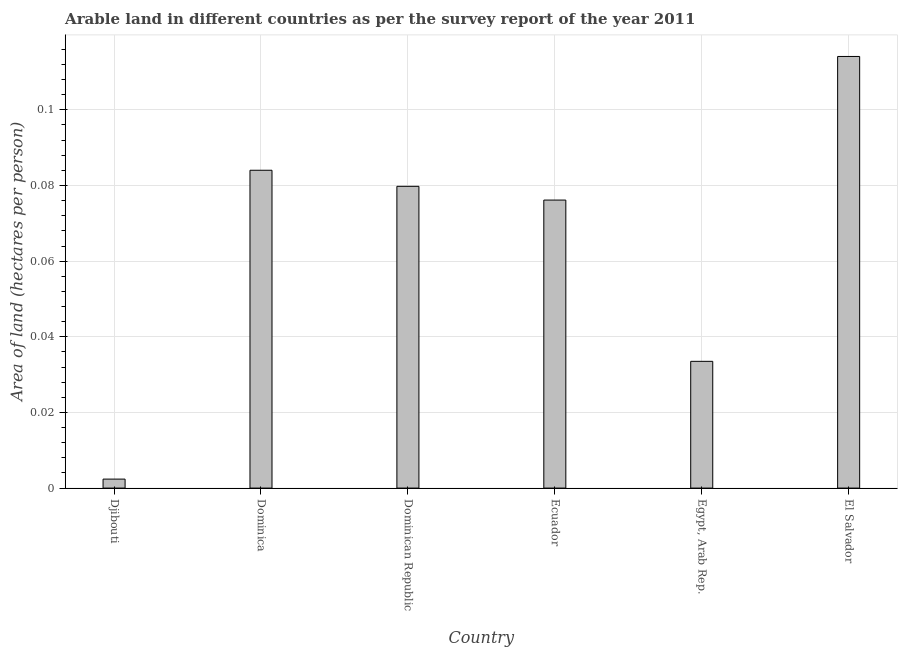Does the graph contain any zero values?
Your answer should be compact. No. Does the graph contain grids?
Your answer should be compact. Yes. What is the title of the graph?
Give a very brief answer. Arable land in different countries as per the survey report of the year 2011. What is the label or title of the X-axis?
Provide a succinct answer. Country. What is the label or title of the Y-axis?
Your answer should be very brief. Area of land (hectares per person). What is the area of arable land in El Salvador?
Provide a succinct answer. 0.11. Across all countries, what is the maximum area of arable land?
Your response must be concise. 0.11. Across all countries, what is the minimum area of arable land?
Provide a short and direct response. 0. In which country was the area of arable land maximum?
Offer a terse response. El Salvador. In which country was the area of arable land minimum?
Your answer should be compact. Djibouti. What is the sum of the area of arable land?
Your answer should be very brief. 0.39. What is the difference between the area of arable land in Dominica and El Salvador?
Provide a short and direct response. -0.03. What is the average area of arable land per country?
Provide a short and direct response. 0.07. What is the median area of arable land?
Your answer should be very brief. 0.08. In how many countries, is the area of arable land greater than 0.068 hectares per person?
Ensure brevity in your answer.  4. What is the ratio of the area of arable land in Dominica to that in Egypt, Arab Rep.?
Offer a very short reply. 2.51. Is the difference between the area of arable land in Dominican Republic and El Salvador greater than the difference between any two countries?
Ensure brevity in your answer.  No. What is the difference between the highest and the lowest area of arable land?
Provide a short and direct response. 0.11. In how many countries, is the area of arable land greater than the average area of arable land taken over all countries?
Provide a short and direct response. 4. How many countries are there in the graph?
Your response must be concise. 6. What is the difference between two consecutive major ticks on the Y-axis?
Provide a succinct answer. 0.02. Are the values on the major ticks of Y-axis written in scientific E-notation?
Your answer should be compact. No. What is the Area of land (hectares per person) in Djibouti?
Provide a short and direct response. 0. What is the Area of land (hectares per person) of Dominica?
Offer a very short reply. 0.08. What is the Area of land (hectares per person) in Dominican Republic?
Provide a short and direct response. 0.08. What is the Area of land (hectares per person) of Ecuador?
Provide a short and direct response. 0.08. What is the Area of land (hectares per person) in Egypt, Arab Rep.?
Keep it short and to the point. 0.03. What is the Area of land (hectares per person) in El Salvador?
Your response must be concise. 0.11. What is the difference between the Area of land (hectares per person) in Djibouti and Dominica?
Offer a very short reply. -0.08. What is the difference between the Area of land (hectares per person) in Djibouti and Dominican Republic?
Give a very brief answer. -0.08. What is the difference between the Area of land (hectares per person) in Djibouti and Ecuador?
Your answer should be compact. -0.07. What is the difference between the Area of land (hectares per person) in Djibouti and Egypt, Arab Rep.?
Make the answer very short. -0.03. What is the difference between the Area of land (hectares per person) in Djibouti and El Salvador?
Your answer should be compact. -0.11. What is the difference between the Area of land (hectares per person) in Dominica and Dominican Republic?
Ensure brevity in your answer.  0. What is the difference between the Area of land (hectares per person) in Dominica and Ecuador?
Your answer should be compact. 0.01. What is the difference between the Area of land (hectares per person) in Dominica and Egypt, Arab Rep.?
Your answer should be very brief. 0.05. What is the difference between the Area of land (hectares per person) in Dominica and El Salvador?
Your answer should be very brief. -0.03. What is the difference between the Area of land (hectares per person) in Dominican Republic and Ecuador?
Your answer should be compact. 0. What is the difference between the Area of land (hectares per person) in Dominican Republic and Egypt, Arab Rep.?
Your answer should be very brief. 0.05. What is the difference between the Area of land (hectares per person) in Dominican Republic and El Salvador?
Your answer should be compact. -0.03. What is the difference between the Area of land (hectares per person) in Ecuador and Egypt, Arab Rep.?
Provide a short and direct response. 0.04. What is the difference between the Area of land (hectares per person) in Ecuador and El Salvador?
Your answer should be very brief. -0.04. What is the difference between the Area of land (hectares per person) in Egypt, Arab Rep. and El Salvador?
Offer a terse response. -0.08. What is the ratio of the Area of land (hectares per person) in Djibouti to that in Dominica?
Make the answer very short. 0.03. What is the ratio of the Area of land (hectares per person) in Djibouti to that in Dominican Republic?
Your response must be concise. 0.03. What is the ratio of the Area of land (hectares per person) in Djibouti to that in Ecuador?
Make the answer very short. 0.03. What is the ratio of the Area of land (hectares per person) in Djibouti to that in Egypt, Arab Rep.?
Provide a succinct answer. 0.07. What is the ratio of the Area of land (hectares per person) in Djibouti to that in El Salvador?
Give a very brief answer. 0.02. What is the ratio of the Area of land (hectares per person) in Dominica to that in Dominican Republic?
Your answer should be very brief. 1.05. What is the ratio of the Area of land (hectares per person) in Dominica to that in Ecuador?
Your response must be concise. 1.1. What is the ratio of the Area of land (hectares per person) in Dominica to that in Egypt, Arab Rep.?
Offer a very short reply. 2.51. What is the ratio of the Area of land (hectares per person) in Dominica to that in El Salvador?
Provide a succinct answer. 0.74. What is the ratio of the Area of land (hectares per person) in Dominican Republic to that in Ecuador?
Keep it short and to the point. 1.05. What is the ratio of the Area of land (hectares per person) in Dominican Republic to that in Egypt, Arab Rep.?
Offer a very short reply. 2.38. What is the ratio of the Area of land (hectares per person) in Dominican Republic to that in El Salvador?
Offer a terse response. 0.7. What is the ratio of the Area of land (hectares per person) in Ecuador to that in Egypt, Arab Rep.?
Ensure brevity in your answer.  2.27. What is the ratio of the Area of land (hectares per person) in Ecuador to that in El Salvador?
Ensure brevity in your answer.  0.67. What is the ratio of the Area of land (hectares per person) in Egypt, Arab Rep. to that in El Salvador?
Give a very brief answer. 0.29. 